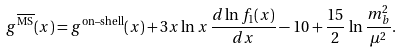<formula> <loc_0><loc_0><loc_500><loc_500>g ^ { \overline { \text {MS} } } ( x ) = g ^ { \text {on--shell} } ( x ) + 3 x \ln x \, \frac { d \ln f _ { 1 } ( x ) } { d x } - 1 0 + \frac { 1 5 } { 2 } \, \ln \frac { m _ { b } ^ { 2 } } { \mu ^ { 2 } } .</formula> 